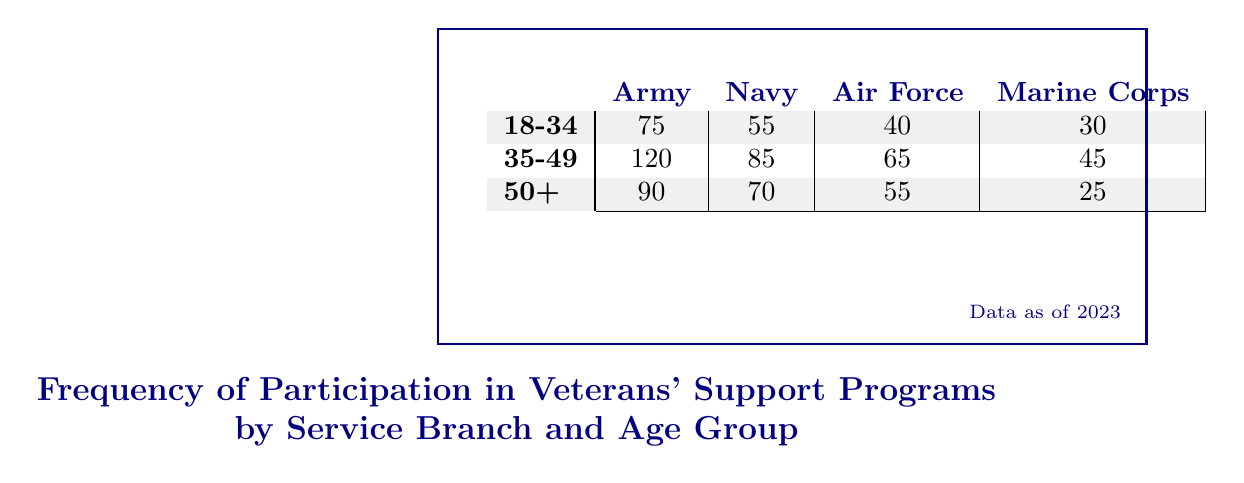What is the participation count for the Army in the age group 35-49? The table shows the participation counts for each service branch by age group. For the Army in the age group 35-49, the participation count is specifically listed as 120.
Answer: 120 Which service branch has the highest participation count in the 18-34 age group? Looking at the 18-34 age group row, the participation counts are: Army 75, Navy 55, Air Force 40, and Marine Corps 30. The Army has the highest count at 75.
Answer: Army How many total participants are there across all age groups for the Navy? To find the total for the Navy, sum the participation counts across all age groups: 55 (18-34) + 85 (35-49) + 70 (50+) = 210.
Answer: 210 Is the participation count for the Marine Corps in the 50+ age group greater than that of the Air Force in the same age group? The table shows 25 participants for the Marine Corps and 55 for the Air Force in the 50+ age group. Since 25 is less than 55, the statement is false.
Answer: No What is the average participation count for the Army across all age groups? The participation counts for the Army are: 75 (18-34), 120 (35-49), and 90 (50+). The sum is 75 + 120 + 90 = 285; there are 3 age groups, so the average is 285 / 3 = 95.
Answer: 95 In which age group does the Air Force have the least participation? The participation counts for the Air Force are: 40 (18-34), 65 (35-49), and 55 (50+). The least count is 40 in the 18-34 age group.
Answer: 18-34 What is the difference in participation count between the Navy in the 35-49 age group and the Marine Corps in the same age group? The Navy has 85 participants and the Marine Corps has 45 in the 35-49 age group. The difference is 85 - 45 = 40.
Answer: 40 Does the Army have more participants than the total of the other branches combined in the 50+ age group? The Army has 90 in the 50+ age group, while the others have: Navy 70, Air Force 55, and Marine Corps 25; the combined total for others is 70 + 55 + 25 = 150. Since 90 is less than 150, the statement is false.
Answer: No 